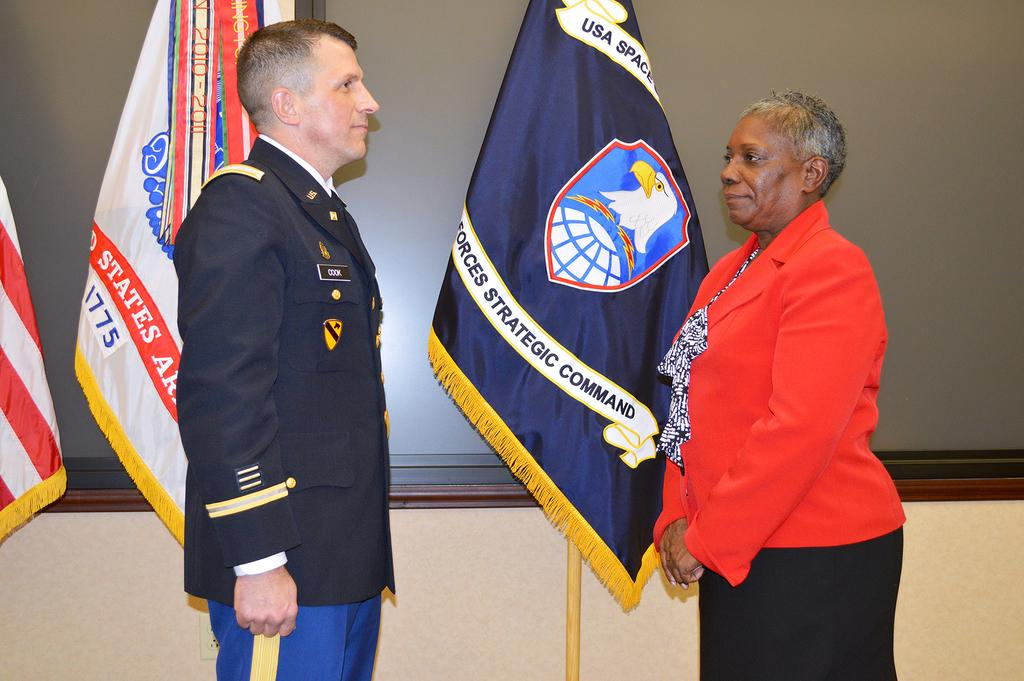<image>
Provide a brief description of the given image. Person standing in front of a flag which says "Strategic Command". 